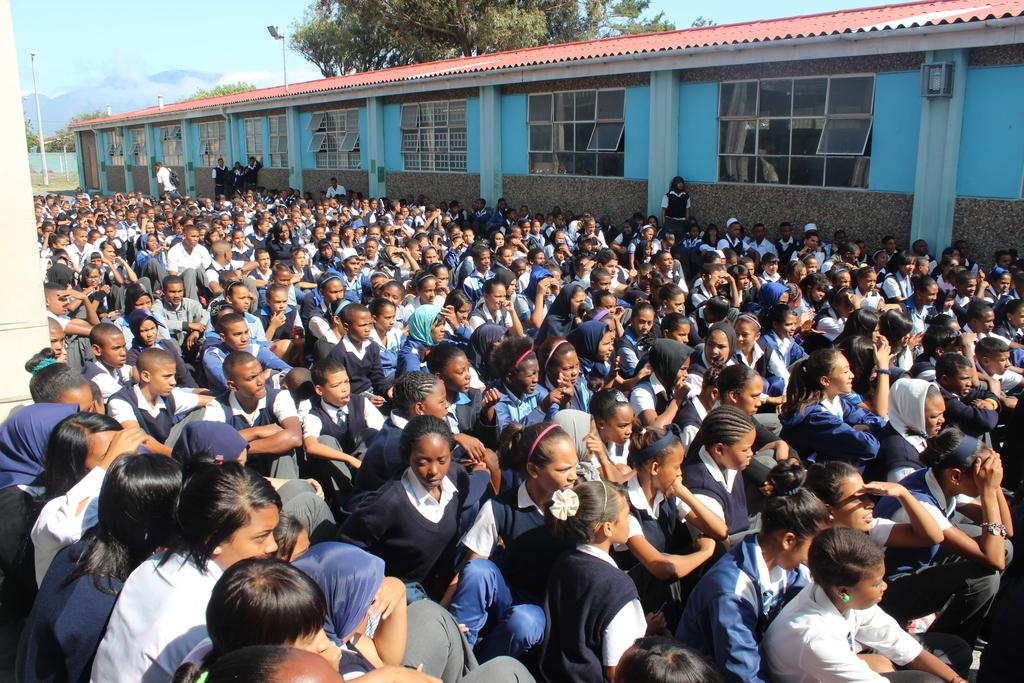What are the people in the image doing? There is a group of people sitting and people standing in the image. What can be seen in the background of the image? There is a building and trees in the background of the image. What object is present in the image that is not a person or part of the background? There is a pole in the image. What is the color of the sky in the image? The sky is blue in the image. Can you see an owl perched on the pole in the image? There is no owl present in the image; only people, a pole, and the background can be seen. What type of division is being performed by the people in the image? There is no division being performed by the people in the image; they are simply sitting or standing. 